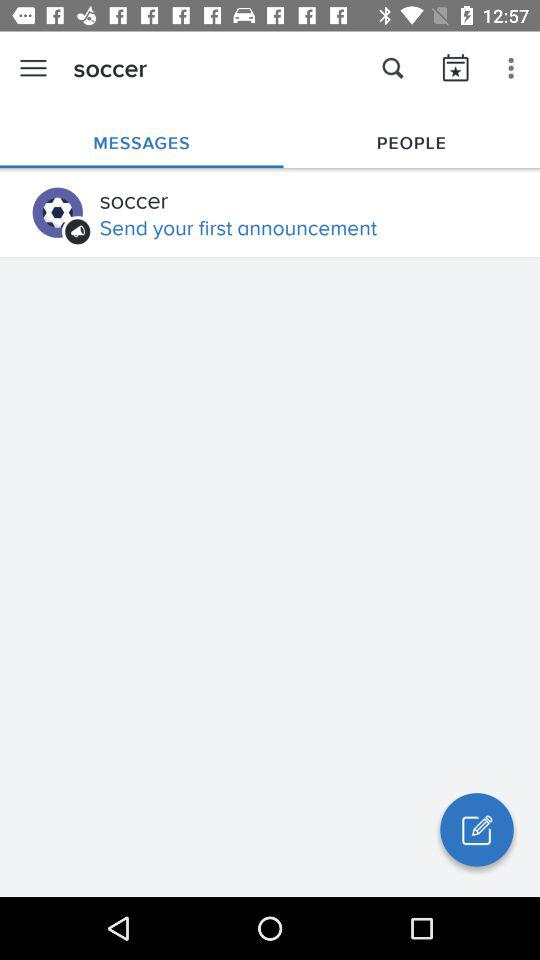Which tab is selected in the "soccer" category? The selected tab is "MESSAGES". 